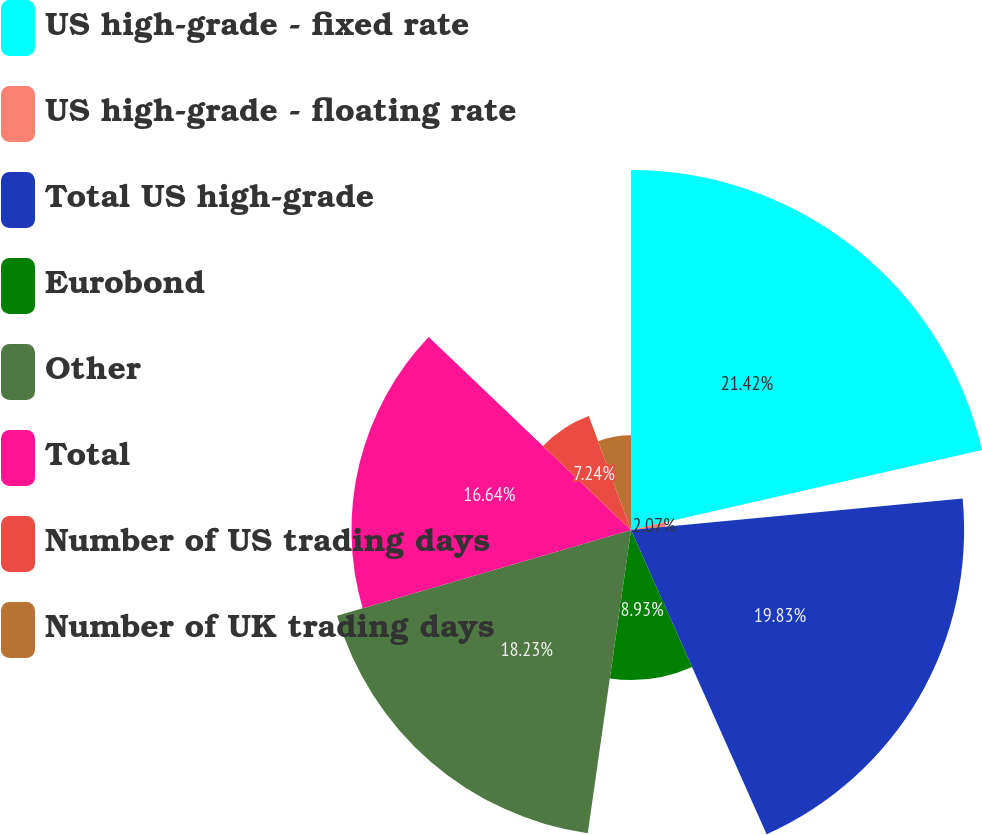<chart> <loc_0><loc_0><loc_500><loc_500><pie_chart><fcel>US high-grade - fixed rate<fcel>US high-grade - floating rate<fcel>Total US high-grade<fcel>Eurobond<fcel>Other<fcel>Total<fcel>Number of US trading days<fcel>Number of UK trading days<nl><fcel>21.43%<fcel>2.07%<fcel>19.83%<fcel>8.93%<fcel>18.23%<fcel>16.64%<fcel>7.24%<fcel>5.64%<nl></chart> 